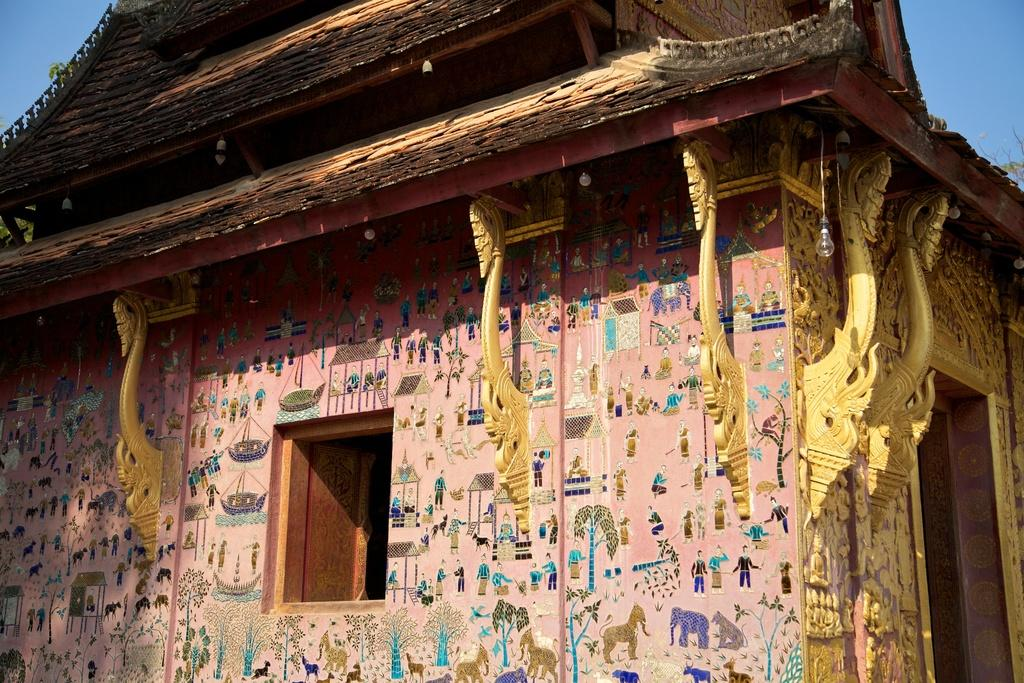What is the location of the person taking the image? The image is taken from outside of a building. What can be seen through the window in the image? There is a window visible in the middle of the image. What is visible at the top of the image? The sky is visible at the top of the image. What type of meal is being served in the image? There is no meal present in the image; it only features a window and the sky. What is the government's stance on the issue depicted in the image? The image does not depict any issue or political context, so it is not possible to determine the government's stance. 